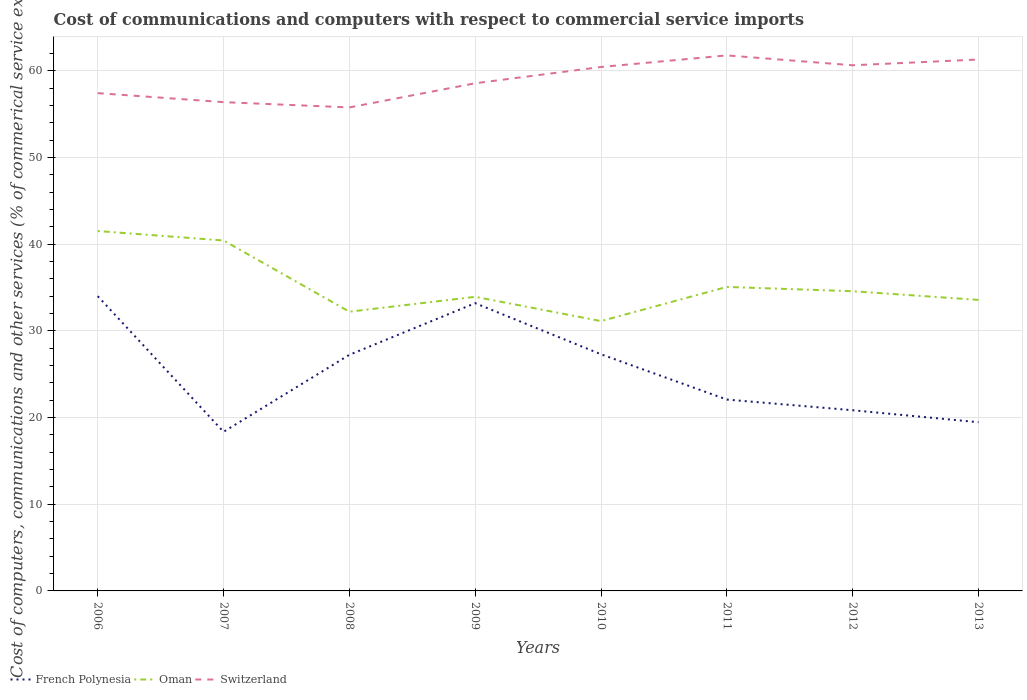Across all years, what is the maximum cost of communications and computers in French Polynesia?
Your answer should be very brief. 18.36. What is the total cost of communications and computers in French Polynesia in the graph?
Your answer should be very brief. 13.16. What is the difference between the highest and the second highest cost of communications and computers in Switzerland?
Provide a short and direct response. 6. Is the cost of communications and computers in French Polynesia strictly greater than the cost of communications and computers in Oman over the years?
Give a very brief answer. Yes. How many lines are there?
Offer a very short reply. 3. Does the graph contain any zero values?
Keep it short and to the point. No. Does the graph contain grids?
Ensure brevity in your answer.  Yes. Where does the legend appear in the graph?
Give a very brief answer. Bottom left. How are the legend labels stacked?
Your answer should be very brief. Horizontal. What is the title of the graph?
Your response must be concise. Cost of communications and computers with respect to commercial service imports. Does "Germany" appear as one of the legend labels in the graph?
Make the answer very short. No. What is the label or title of the X-axis?
Give a very brief answer. Years. What is the label or title of the Y-axis?
Your answer should be very brief. Cost of computers, communications and other services (% of commerical service exports). What is the Cost of computers, communications and other services (% of commerical service exports) in French Polynesia in 2006?
Provide a short and direct response. 34. What is the Cost of computers, communications and other services (% of commerical service exports) of Oman in 2006?
Offer a terse response. 41.52. What is the Cost of computers, communications and other services (% of commerical service exports) in Switzerland in 2006?
Provide a succinct answer. 57.43. What is the Cost of computers, communications and other services (% of commerical service exports) in French Polynesia in 2007?
Provide a short and direct response. 18.36. What is the Cost of computers, communications and other services (% of commerical service exports) in Oman in 2007?
Offer a terse response. 40.43. What is the Cost of computers, communications and other services (% of commerical service exports) in Switzerland in 2007?
Offer a very short reply. 56.39. What is the Cost of computers, communications and other services (% of commerical service exports) in French Polynesia in 2008?
Provide a succinct answer. 27.24. What is the Cost of computers, communications and other services (% of commerical service exports) of Oman in 2008?
Keep it short and to the point. 32.21. What is the Cost of computers, communications and other services (% of commerical service exports) of Switzerland in 2008?
Offer a terse response. 55.78. What is the Cost of computers, communications and other services (% of commerical service exports) in French Polynesia in 2009?
Your answer should be very brief. 33.2. What is the Cost of computers, communications and other services (% of commerical service exports) in Oman in 2009?
Ensure brevity in your answer.  33.93. What is the Cost of computers, communications and other services (% of commerical service exports) of Switzerland in 2009?
Keep it short and to the point. 58.57. What is the Cost of computers, communications and other services (% of commerical service exports) in French Polynesia in 2010?
Ensure brevity in your answer.  27.3. What is the Cost of computers, communications and other services (% of commerical service exports) in Oman in 2010?
Keep it short and to the point. 31.13. What is the Cost of computers, communications and other services (% of commerical service exports) of Switzerland in 2010?
Provide a short and direct response. 60.44. What is the Cost of computers, communications and other services (% of commerical service exports) of French Polynesia in 2011?
Your answer should be compact. 22.08. What is the Cost of computers, communications and other services (% of commerical service exports) of Oman in 2011?
Ensure brevity in your answer.  35.07. What is the Cost of computers, communications and other services (% of commerical service exports) in Switzerland in 2011?
Provide a succinct answer. 61.78. What is the Cost of computers, communications and other services (% of commerical service exports) of French Polynesia in 2012?
Provide a short and direct response. 20.84. What is the Cost of computers, communications and other services (% of commerical service exports) of Oman in 2012?
Your response must be concise. 34.57. What is the Cost of computers, communications and other services (% of commerical service exports) of Switzerland in 2012?
Your answer should be compact. 60.64. What is the Cost of computers, communications and other services (% of commerical service exports) of French Polynesia in 2013?
Your answer should be compact. 19.46. What is the Cost of computers, communications and other services (% of commerical service exports) in Oman in 2013?
Your answer should be compact. 33.58. What is the Cost of computers, communications and other services (% of commerical service exports) in Switzerland in 2013?
Offer a very short reply. 61.31. Across all years, what is the maximum Cost of computers, communications and other services (% of commerical service exports) of French Polynesia?
Keep it short and to the point. 34. Across all years, what is the maximum Cost of computers, communications and other services (% of commerical service exports) of Oman?
Ensure brevity in your answer.  41.52. Across all years, what is the maximum Cost of computers, communications and other services (% of commerical service exports) of Switzerland?
Your answer should be very brief. 61.78. Across all years, what is the minimum Cost of computers, communications and other services (% of commerical service exports) in French Polynesia?
Give a very brief answer. 18.36. Across all years, what is the minimum Cost of computers, communications and other services (% of commerical service exports) of Oman?
Give a very brief answer. 31.13. Across all years, what is the minimum Cost of computers, communications and other services (% of commerical service exports) in Switzerland?
Offer a very short reply. 55.78. What is the total Cost of computers, communications and other services (% of commerical service exports) of French Polynesia in the graph?
Offer a very short reply. 202.48. What is the total Cost of computers, communications and other services (% of commerical service exports) in Oman in the graph?
Ensure brevity in your answer.  282.44. What is the total Cost of computers, communications and other services (% of commerical service exports) of Switzerland in the graph?
Offer a very short reply. 472.34. What is the difference between the Cost of computers, communications and other services (% of commerical service exports) in French Polynesia in 2006 and that in 2007?
Your answer should be very brief. 15.65. What is the difference between the Cost of computers, communications and other services (% of commerical service exports) of Oman in 2006 and that in 2007?
Your answer should be compact. 1.09. What is the difference between the Cost of computers, communications and other services (% of commerical service exports) of Switzerland in 2006 and that in 2007?
Provide a short and direct response. 1.04. What is the difference between the Cost of computers, communications and other services (% of commerical service exports) of French Polynesia in 2006 and that in 2008?
Offer a terse response. 6.76. What is the difference between the Cost of computers, communications and other services (% of commerical service exports) of Oman in 2006 and that in 2008?
Your answer should be very brief. 9.31. What is the difference between the Cost of computers, communications and other services (% of commerical service exports) in Switzerland in 2006 and that in 2008?
Offer a very short reply. 1.65. What is the difference between the Cost of computers, communications and other services (% of commerical service exports) of French Polynesia in 2006 and that in 2009?
Make the answer very short. 0.81. What is the difference between the Cost of computers, communications and other services (% of commerical service exports) of Oman in 2006 and that in 2009?
Give a very brief answer. 7.59. What is the difference between the Cost of computers, communications and other services (% of commerical service exports) of Switzerland in 2006 and that in 2009?
Keep it short and to the point. -1.14. What is the difference between the Cost of computers, communications and other services (% of commerical service exports) of French Polynesia in 2006 and that in 2010?
Give a very brief answer. 6.7. What is the difference between the Cost of computers, communications and other services (% of commerical service exports) of Oman in 2006 and that in 2010?
Provide a succinct answer. 10.39. What is the difference between the Cost of computers, communications and other services (% of commerical service exports) of Switzerland in 2006 and that in 2010?
Keep it short and to the point. -3.02. What is the difference between the Cost of computers, communications and other services (% of commerical service exports) of French Polynesia in 2006 and that in 2011?
Provide a short and direct response. 11.93. What is the difference between the Cost of computers, communications and other services (% of commerical service exports) in Oman in 2006 and that in 2011?
Offer a terse response. 6.45. What is the difference between the Cost of computers, communications and other services (% of commerical service exports) of Switzerland in 2006 and that in 2011?
Your response must be concise. -4.35. What is the difference between the Cost of computers, communications and other services (% of commerical service exports) in French Polynesia in 2006 and that in 2012?
Offer a very short reply. 13.16. What is the difference between the Cost of computers, communications and other services (% of commerical service exports) of Oman in 2006 and that in 2012?
Provide a succinct answer. 6.94. What is the difference between the Cost of computers, communications and other services (% of commerical service exports) of Switzerland in 2006 and that in 2012?
Offer a terse response. -3.21. What is the difference between the Cost of computers, communications and other services (% of commerical service exports) in French Polynesia in 2006 and that in 2013?
Keep it short and to the point. 14.54. What is the difference between the Cost of computers, communications and other services (% of commerical service exports) of Oman in 2006 and that in 2013?
Your response must be concise. 7.94. What is the difference between the Cost of computers, communications and other services (% of commerical service exports) of Switzerland in 2006 and that in 2013?
Keep it short and to the point. -3.88. What is the difference between the Cost of computers, communications and other services (% of commerical service exports) in French Polynesia in 2007 and that in 2008?
Your answer should be compact. -8.88. What is the difference between the Cost of computers, communications and other services (% of commerical service exports) of Oman in 2007 and that in 2008?
Make the answer very short. 8.22. What is the difference between the Cost of computers, communications and other services (% of commerical service exports) of Switzerland in 2007 and that in 2008?
Your response must be concise. 0.61. What is the difference between the Cost of computers, communications and other services (% of commerical service exports) of French Polynesia in 2007 and that in 2009?
Provide a short and direct response. -14.84. What is the difference between the Cost of computers, communications and other services (% of commerical service exports) of Oman in 2007 and that in 2009?
Offer a terse response. 6.5. What is the difference between the Cost of computers, communications and other services (% of commerical service exports) of Switzerland in 2007 and that in 2009?
Provide a short and direct response. -2.18. What is the difference between the Cost of computers, communications and other services (% of commerical service exports) of French Polynesia in 2007 and that in 2010?
Make the answer very short. -8.95. What is the difference between the Cost of computers, communications and other services (% of commerical service exports) in Oman in 2007 and that in 2010?
Make the answer very short. 9.3. What is the difference between the Cost of computers, communications and other services (% of commerical service exports) in Switzerland in 2007 and that in 2010?
Keep it short and to the point. -4.06. What is the difference between the Cost of computers, communications and other services (% of commerical service exports) in French Polynesia in 2007 and that in 2011?
Offer a very short reply. -3.72. What is the difference between the Cost of computers, communications and other services (% of commerical service exports) in Oman in 2007 and that in 2011?
Your response must be concise. 5.36. What is the difference between the Cost of computers, communications and other services (% of commerical service exports) in Switzerland in 2007 and that in 2011?
Ensure brevity in your answer.  -5.39. What is the difference between the Cost of computers, communications and other services (% of commerical service exports) in French Polynesia in 2007 and that in 2012?
Provide a succinct answer. -2.49. What is the difference between the Cost of computers, communications and other services (% of commerical service exports) in Oman in 2007 and that in 2012?
Provide a succinct answer. 5.85. What is the difference between the Cost of computers, communications and other services (% of commerical service exports) in Switzerland in 2007 and that in 2012?
Make the answer very short. -4.25. What is the difference between the Cost of computers, communications and other services (% of commerical service exports) in French Polynesia in 2007 and that in 2013?
Offer a terse response. -1.11. What is the difference between the Cost of computers, communications and other services (% of commerical service exports) of Oman in 2007 and that in 2013?
Ensure brevity in your answer.  6.85. What is the difference between the Cost of computers, communications and other services (% of commerical service exports) in Switzerland in 2007 and that in 2013?
Keep it short and to the point. -4.92. What is the difference between the Cost of computers, communications and other services (% of commerical service exports) of French Polynesia in 2008 and that in 2009?
Provide a short and direct response. -5.96. What is the difference between the Cost of computers, communications and other services (% of commerical service exports) of Oman in 2008 and that in 2009?
Give a very brief answer. -1.72. What is the difference between the Cost of computers, communications and other services (% of commerical service exports) in Switzerland in 2008 and that in 2009?
Your answer should be compact. -2.79. What is the difference between the Cost of computers, communications and other services (% of commerical service exports) of French Polynesia in 2008 and that in 2010?
Offer a very short reply. -0.06. What is the difference between the Cost of computers, communications and other services (% of commerical service exports) in Switzerland in 2008 and that in 2010?
Offer a terse response. -4.67. What is the difference between the Cost of computers, communications and other services (% of commerical service exports) of French Polynesia in 2008 and that in 2011?
Provide a short and direct response. 5.16. What is the difference between the Cost of computers, communications and other services (% of commerical service exports) of Oman in 2008 and that in 2011?
Your response must be concise. -2.86. What is the difference between the Cost of computers, communications and other services (% of commerical service exports) of Switzerland in 2008 and that in 2011?
Give a very brief answer. -6. What is the difference between the Cost of computers, communications and other services (% of commerical service exports) of French Polynesia in 2008 and that in 2012?
Make the answer very short. 6.39. What is the difference between the Cost of computers, communications and other services (% of commerical service exports) in Oman in 2008 and that in 2012?
Your response must be concise. -2.36. What is the difference between the Cost of computers, communications and other services (% of commerical service exports) of Switzerland in 2008 and that in 2012?
Your response must be concise. -4.86. What is the difference between the Cost of computers, communications and other services (% of commerical service exports) in French Polynesia in 2008 and that in 2013?
Provide a succinct answer. 7.78. What is the difference between the Cost of computers, communications and other services (% of commerical service exports) of Oman in 2008 and that in 2013?
Make the answer very short. -1.36. What is the difference between the Cost of computers, communications and other services (% of commerical service exports) in Switzerland in 2008 and that in 2013?
Provide a short and direct response. -5.53. What is the difference between the Cost of computers, communications and other services (% of commerical service exports) of French Polynesia in 2009 and that in 2010?
Provide a short and direct response. 5.9. What is the difference between the Cost of computers, communications and other services (% of commerical service exports) in Oman in 2009 and that in 2010?
Provide a short and direct response. 2.8. What is the difference between the Cost of computers, communications and other services (% of commerical service exports) of Switzerland in 2009 and that in 2010?
Ensure brevity in your answer.  -1.88. What is the difference between the Cost of computers, communications and other services (% of commerical service exports) in French Polynesia in 2009 and that in 2011?
Give a very brief answer. 11.12. What is the difference between the Cost of computers, communications and other services (% of commerical service exports) in Oman in 2009 and that in 2011?
Keep it short and to the point. -1.14. What is the difference between the Cost of computers, communications and other services (% of commerical service exports) in Switzerland in 2009 and that in 2011?
Give a very brief answer. -3.21. What is the difference between the Cost of computers, communications and other services (% of commerical service exports) in French Polynesia in 2009 and that in 2012?
Offer a very short reply. 12.35. What is the difference between the Cost of computers, communications and other services (% of commerical service exports) in Oman in 2009 and that in 2012?
Make the answer very short. -0.64. What is the difference between the Cost of computers, communications and other services (% of commerical service exports) of Switzerland in 2009 and that in 2012?
Keep it short and to the point. -2.07. What is the difference between the Cost of computers, communications and other services (% of commerical service exports) of French Polynesia in 2009 and that in 2013?
Your answer should be compact. 13.73. What is the difference between the Cost of computers, communications and other services (% of commerical service exports) of Oman in 2009 and that in 2013?
Keep it short and to the point. 0.36. What is the difference between the Cost of computers, communications and other services (% of commerical service exports) of Switzerland in 2009 and that in 2013?
Ensure brevity in your answer.  -2.74. What is the difference between the Cost of computers, communications and other services (% of commerical service exports) in French Polynesia in 2010 and that in 2011?
Your answer should be very brief. 5.22. What is the difference between the Cost of computers, communications and other services (% of commerical service exports) of Oman in 2010 and that in 2011?
Offer a very short reply. -3.94. What is the difference between the Cost of computers, communications and other services (% of commerical service exports) of Switzerland in 2010 and that in 2011?
Your answer should be compact. -1.34. What is the difference between the Cost of computers, communications and other services (% of commerical service exports) in French Polynesia in 2010 and that in 2012?
Make the answer very short. 6.46. What is the difference between the Cost of computers, communications and other services (% of commerical service exports) in Oman in 2010 and that in 2012?
Ensure brevity in your answer.  -3.45. What is the difference between the Cost of computers, communications and other services (% of commerical service exports) of Switzerland in 2010 and that in 2012?
Offer a terse response. -0.2. What is the difference between the Cost of computers, communications and other services (% of commerical service exports) of French Polynesia in 2010 and that in 2013?
Offer a terse response. 7.84. What is the difference between the Cost of computers, communications and other services (% of commerical service exports) of Oman in 2010 and that in 2013?
Offer a very short reply. -2.45. What is the difference between the Cost of computers, communications and other services (% of commerical service exports) of Switzerland in 2010 and that in 2013?
Provide a succinct answer. -0.86. What is the difference between the Cost of computers, communications and other services (% of commerical service exports) of French Polynesia in 2011 and that in 2012?
Provide a succinct answer. 1.23. What is the difference between the Cost of computers, communications and other services (% of commerical service exports) in Oman in 2011 and that in 2012?
Ensure brevity in your answer.  0.5. What is the difference between the Cost of computers, communications and other services (% of commerical service exports) of Switzerland in 2011 and that in 2012?
Your answer should be very brief. 1.14. What is the difference between the Cost of computers, communications and other services (% of commerical service exports) in French Polynesia in 2011 and that in 2013?
Offer a terse response. 2.61. What is the difference between the Cost of computers, communications and other services (% of commerical service exports) in Oman in 2011 and that in 2013?
Provide a short and direct response. 1.49. What is the difference between the Cost of computers, communications and other services (% of commerical service exports) in Switzerland in 2011 and that in 2013?
Offer a terse response. 0.47. What is the difference between the Cost of computers, communications and other services (% of commerical service exports) in French Polynesia in 2012 and that in 2013?
Make the answer very short. 1.38. What is the difference between the Cost of computers, communications and other services (% of commerical service exports) of Switzerland in 2012 and that in 2013?
Make the answer very short. -0.67. What is the difference between the Cost of computers, communications and other services (% of commerical service exports) of French Polynesia in 2006 and the Cost of computers, communications and other services (% of commerical service exports) of Oman in 2007?
Ensure brevity in your answer.  -6.42. What is the difference between the Cost of computers, communications and other services (% of commerical service exports) of French Polynesia in 2006 and the Cost of computers, communications and other services (% of commerical service exports) of Switzerland in 2007?
Your answer should be very brief. -22.39. What is the difference between the Cost of computers, communications and other services (% of commerical service exports) of Oman in 2006 and the Cost of computers, communications and other services (% of commerical service exports) of Switzerland in 2007?
Provide a succinct answer. -14.87. What is the difference between the Cost of computers, communications and other services (% of commerical service exports) of French Polynesia in 2006 and the Cost of computers, communications and other services (% of commerical service exports) of Oman in 2008?
Your answer should be compact. 1.79. What is the difference between the Cost of computers, communications and other services (% of commerical service exports) in French Polynesia in 2006 and the Cost of computers, communications and other services (% of commerical service exports) in Switzerland in 2008?
Provide a succinct answer. -21.77. What is the difference between the Cost of computers, communications and other services (% of commerical service exports) of Oman in 2006 and the Cost of computers, communications and other services (% of commerical service exports) of Switzerland in 2008?
Give a very brief answer. -14.26. What is the difference between the Cost of computers, communications and other services (% of commerical service exports) of French Polynesia in 2006 and the Cost of computers, communications and other services (% of commerical service exports) of Oman in 2009?
Make the answer very short. 0.07. What is the difference between the Cost of computers, communications and other services (% of commerical service exports) in French Polynesia in 2006 and the Cost of computers, communications and other services (% of commerical service exports) in Switzerland in 2009?
Your answer should be compact. -24.56. What is the difference between the Cost of computers, communications and other services (% of commerical service exports) of Oman in 2006 and the Cost of computers, communications and other services (% of commerical service exports) of Switzerland in 2009?
Offer a terse response. -17.05. What is the difference between the Cost of computers, communications and other services (% of commerical service exports) in French Polynesia in 2006 and the Cost of computers, communications and other services (% of commerical service exports) in Oman in 2010?
Give a very brief answer. 2.87. What is the difference between the Cost of computers, communications and other services (% of commerical service exports) of French Polynesia in 2006 and the Cost of computers, communications and other services (% of commerical service exports) of Switzerland in 2010?
Offer a terse response. -26.44. What is the difference between the Cost of computers, communications and other services (% of commerical service exports) in Oman in 2006 and the Cost of computers, communications and other services (% of commerical service exports) in Switzerland in 2010?
Keep it short and to the point. -18.93. What is the difference between the Cost of computers, communications and other services (% of commerical service exports) in French Polynesia in 2006 and the Cost of computers, communications and other services (% of commerical service exports) in Oman in 2011?
Offer a terse response. -1.07. What is the difference between the Cost of computers, communications and other services (% of commerical service exports) in French Polynesia in 2006 and the Cost of computers, communications and other services (% of commerical service exports) in Switzerland in 2011?
Provide a succinct answer. -27.78. What is the difference between the Cost of computers, communications and other services (% of commerical service exports) of Oman in 2006 and the Cost of computers, communications and other services (% of commerical service exports) of Switzerland in 2011?
Your answer should be very brief. -20.26. What is the difference between the Cost of computers, communications and other services (% of commerical service exports) in French Polynesia in 2006 and the Cost of computers, communications and other services (% of commerical service exports) in Oman in 2012?
Offer a terse response. -0.57. What is the difference between the Cost of computers, communications and other services (% of commerical service exports) in French Polynesia in 2006 and the Cost of computers, communications and other services (% of commerical service exports) in Switzerland in 2012?
Keep it short and to the point. -26.64. What is the difference between the Cost of computers, communications and other services (% of commerical service exports) in Oman in 2006 and the Cost of computers, communications and other services (% of commerical service exports) in Switzerland in 2012?
Ensure brevity in your answer.  -19.12. What is the difference between the Cost of computers, communications and other services (% of commerical service exports) in French Polynesia in 2006 and the Cost of computers, communications and other services (% of commerical service exports) in Oman in 2013?
Offer a terse response. 0.43. What is the difference between the Cost of computers, communications and other services (% of commerical service exports) of French Polynesia in 2006 and the Cost of computers, communications and other services (% of commerical service exports) of Switzerland in 2013?
Keep it short and to the point. -27.3. What is the difference between the Cost of computers, communications and other services (% of commerical service exports) of Oman in 2006 and the Cost of computers, communications and other services (% of commerical service exports) of Switzerland in 2013?
Ensure brevity in your answer.  -19.79. What is the difference between the Cost of computers, communications and other services (% of commerical service exports) of French Polynesia in 2007 and the Cost of computers, communications and other services (% of commerical service exports) of Oman in 2008?
Your answer should be very brief. -13.86. What is the difference between the Cost of computers, communications and other services (% of commerical service exports) of French Polynesia in 2007 and the Cost of computers, communications and other services (% of commerical service exports) of Switzerland in 2008?
Provide a short and direct response. -37.42. What is the difference between the Cost of computers, communications and other services (% of commerical service exports) of Oman in 2007 and the Cost of computers, communications and other services (% of commerical service exports) of Switzerland in 2008?
Make the answer very short. -15.35. What is the difference between the Cost of computers, communications and other services (% of commerical service exports) in French Polynesia in 2007 and the Cost of computers, communications and other services (% of commerical service exports) in Oman in 2009?
Your answer should be compact. -15.58. What is the difference between the Cost of computers, communications and other services (% of commerical service exports) of French Polynesia in 2007 and the Cost of computers, communications and other services (% of commerical service exports) of Switzerland in 2009?
Your answer should be very brief. -40.21. What is the difference between the Cost of computers, communications and other services (% of commerical service exports) in Oman in 2007 and the Cost of computers, communications and other services (% of commerical service exports) in Switzerland in 2009?
Your response must be concise. -18.14. What is the difference between the Cost of computers, communications and other services (% of commerical service exports) of French Polynesia in 2007 and the Cost of computers, communications and other services (% of commerical service exports) of Oman in 2010?
Offer a very short reply. -12.77. What is the difference between the Cost of computers, communications and other services (% of commerical service exports) of French Polynesia in 2007 and the Cost of computers, communications and other services (% of commerical service exports) of Switzerland in 2010?
Offer a terse response. -42.09. What is the difference between the Cost of computers, communications and other services (% of commerical service exports) in Oman in 2007 and the Cost of computers, communications and other services (% of commerical service exports) in Switzerland in 2010?
Keep it short and to the point. -20.02. What is the difference between the Cost of computers, communications and other services (% of commerical service exports) of French Polynesia in 2007 and the Cost of computers, communications and other services (% of commerical service exports) of Oman in 2011?
Give a very brief answer. -16.72. What is the difference between the Cost of computers, communications and other services (% of commerical service exports) of French Polynesia in 2007 and the Cost of computers, communications and other services (% of commerical service exports) of Switzerland in 2011?
Give a very brief answer. -43.43. What is the difference between the Cost of computers, communications and other services (% of commerical service exports) in Oman in 2007 and the Cost of computers, communications and other services (% of commerical service exports) in Switzerland in 2011?
Your answer should be compact. -21.35. What is the difference between the Cost of computers, communications and other services (% of commerical service exports) in French Polynesia in 2007 and the Cost of computers, communications and other services (% of commerical service exports) in Oman in 2012?
Offer a very short reply. -16.22. What is the difference between the Cost of computers, communications and other services (% of commerical service exports) in French Polynesia in 2007 and the Cost of computers, communications and other services (% of commerical service exports) in Switzerland in 2012?
Offer a terse response. -42.29. What is the difference between the Cost of computers, communications and other services (% of commerical service exports) in Oman in 2007 and the Cost of computers, communications and other services (% of commerical service exports) in Switzerland in 2012?
Ensure brevity in your answer.  -20.21. What is the difference between the Cost of computers, communications and other services (% of commerical service exports) of French Polynesia in 2007 and the Cost of computers, communications and other services (% of commerical service exports) of Oman in 2013?
Ensure brevity in your answer.  -15.22. What is the difference between the Cost of computers, communications and other services (% of commerical service exports) in French Polynesia in 2007 and the Cost of computers, communications and other services (% of commerical service exports) in Switzerland in 2013?
Offer a terse response. -42.95. What is the difference between the Cost of computers, communications and other services (% of commerical service exports) in Oman in 2007 and the Cost of computers, communications and other services (% of commerical service exports) in Switzerland in 2013?
Your answer should be very brief. -20.88. What is the difference between the Cost of computers, communications and other services (% of commerical service exports) of French Polynesia in 2008 and the Cost of computers, communications and other services (% of commerical service exports) of Oman in 2009?
Ensure brevity in your answer.  -6.69. What is the difference between the Cost of computers, communications and other services (% of commerical service exports) of French Polynesia in 2008 and the Cost of computers, communications and other services (% of commerical service exports) of Switzerland in 2009?
Your answer should be very brief. -31.33. What is the difference between the Cost of computers, communications and other services (% of commerical service exports) of Oman in 2008 and the Cost of computers, communications and other services (% of commerical service exports) of Switzerland in 2009?
Offer a very short reply. -26.35. What is the difference between the Cost of computers, communications and other services (% of commerical service exports) of French Polynesia in 2008 and the Cost of computers, communications and other services (% of commerical service exports) of Oman in 2010?
Provide a succinct answer. -3.89. What is the difference between the Cost of computers, communications and other services (% of commerical service exports) of French Polynesia in 2008 and the Cost of computers, communications and other services (% of commerical service exports) of Switzerland in 2010?
Your response must be concise. -33.2. What is the difference between the Cost of computers, communications and other services (% of commerical service exports) of Oman in 2008 and the Cost of computers, communications and other services (% of commerical service exports) of Switzerland in 2010?
Your response must be concise. -28.23. What is the difference between the Cost of computers, communications and other services (% of commerical service exports) of French Polynesia in 2008 and the Cost of computers, communications and other services (% of commerical service exports) of Oman in 2011?
Make the answer very short. -7.83. What is the difference between the Cost of computers, communications and other services (% of commerical service exports) in French Polynesia in 2008 and the Cost of computers, communications and other services (% of commerical service exports) in Switzerland in 2011?
Offer a terse response. -34.54. What is the difference between the Cost of computers, communications and other services (% of commerical service exports) in Oman in 2008 and the Cost of computers, communications and other services (% of commerical service exports) in Switzerland in 2011?
Offer a very short reply. -29.57. What is the difference between the Cost of computers, communications and other services (% of commerical service exports) in French Polynesia in 2008 and the Cost of computers, communications and other services (% of commerical service exports) in Oman in 2012?
Your response must be concise. -7.34. What is the difference between the Cost of computers, communications and other services (% of commerical service exports) of French Polynesia in 2008 and the Cost of computers, communications and other services (% of commerical service exports) of Switzerland in 2012?
Your answer should be very brief. -33.4. What is the difference between the Cost of computers, communications and other services (% of commerical service exports) in Oman in 2008 and the Cost of computers, communications and other services (% of commerical service exports) in Switzerland in 2012?
Offer a very short reply. -28.43. What is the difference between the Cost of computers, communications and other services (% of commerical service exports) in French Polynesia in 2008 and the Cost of computers, communications and other services (% of commerical service exports) in Oman in 2013?
Keep it short and to the point. -6.34. What is the difference between the Cost of computers, communications and other services (% of commerical service exports) in French Polynesia in 2008 and the Cost of computers, communications and other services (% of commerical service exports) in Switzerland in 2013?
Provide a short and direct response. -34.07. What is the difference between the Cost of computers, communications and other services (% of commerical service exports) in Oman in 2008 and the Cost of computers, communications and other services (% of commerical service exports) in Switzerland in 2013?
Offer a terse response. -29.09. What is the difference between the Cost of computers, communications and other services (% of commerical service exports) of French Polynesia in 2009 and the Cost of computers, communications and other services (% of commerical service exports) of Oman in 2010?
Keep it short and to the point. 2.07. What is the difference between the Cost of computers, communications and other services (% of commerical service exports) of French Polynesia in 2009 and the Cost of computers, communications and other services (% of commerical service exports) of Switzerland in 2010?
Give a very brief answer. -27.25. What is the difference between the Cost of computers, communications and other services (% of commerical service exports) of Oman in 2009 and the Cost of computers, communications and other services (% of commerical service exports) of Switzerland in 2010?
Keep it short and to the point. -26.51. What is the difference between the Cost of computers, communications and other services (% of commerical service exports) of French Polynesia in 2009 and the Cost of computers, communications and other services (% of commerical service exports) of Oman in 2011?
Make the answer very short. -1.87. What is the difference between the Cost of computers, communications and other services (% of commerical service exports) of French Polynesia in 2009 and the Cost of computers, communications and other services (% of commerical service exports) of Switzerland in 2011?
Give a very brief answer. -28.58. What is the difference between the Cost of computers, communications and other services (% of commerical service exports) of Oman in 2009 and the Cost of computers, communications and other services (% of commerical service exports) of Switzerland in 2011?
Offer a very short reply. -27.85. What is the difference between the Cost of computers, communications and other services (% of commerical service exports) of French Polynesia in 2009 and the Cost of computers, communications and other services (% of commerical service exports) of Oman in 2012?
Your answer should be very brief. -1.38. What is the difference between the Cost of computers, communications and other services (% of commerical service exports) of French Polynesia in 2009 and the Cost of computers, communications and other services (% of commerical service exports) of Switzerland in 2012?
Your answer should be compact. -27.44. What is the difference between the Cost of computers, communications and other services (% of commerical service exports) of Oman in 2009 and the Cost of computers, communications and other services (% of commerical service exports) of Switzerland in 2012?
Your answer should be very brief. -26.71. What is the difference between the Cost of computers, communications and other services (% of commerical service exports) of French Polynesia in 2009 and the Cost of computers, communications and other services (% of commerical service exports) of Oman in 2013?
Your response must be concise. -0.38. What is the difference between the Cost of computers, communications and other services (% of commerical service exports) in French Polynesia in 2009 and the Cost of computers, communications and other services (% of commerical service exports) in Switzerland in 2013?
Your response must be concise. -28.11. What is the difference between the Cost of computers, communications and other services (% of commerical service exports) of Oman in 2009 and the Cost of computers, communications and other services (% of commerical service exports) of Switzerland in 2013?
Your answer should be very brief. -27.38. What is the difference between the Cost of computers, communications and other services (% of commerical service exports) of French Polynesia in 2010 and the Cost of computers, communications and other services (% of commerical service exports) of Oman in 2011?
Your response must be concise. -7.77. What is the difference between the Cost of computers, communications and other services (% of commerical service exports) of French Polynesia in 2010 and the Cost of computers, communications and other services (% of commerical service exports) of Switzerland in 2011?
Give a very brief answer. -34.48. What is the difference between the Cost of computers, communications and other services (% of commerical service exports) of Oman in 2010 and the Cost of computers, communications and other services (% of commerical service exports) of Switzerland in 2011?
Ensure brevity in your answer.  -30.65. What is the difference between the Cost of computers, communications and other services (% of commerical service exports) in French Polynesia in 2010 and the Cost of computers, communications and other services (% of commerical service exports) in Oman in 2012?
Keep it short and to the point. -7.27. What is the difference between the Cost of computers, communications and other services (% of commerical service exports) in French Polynesia in 2010 and the Cost of computers, communications and other services (% of commerical service exports) in Switzerland in 2012?
Keep it short and to the point. -33.34. What is the difference between the Cost of computers, communications and other services (% of commerical service exports) of Oman in 2010 and the Cost of computers, communications and other services (% of commerical service exports) of Switzerland in 2012?
Offer a terse response. -29.51. What is the difference between the Cost of computers, communications and other services (% of commerical service exports) of French Polynesia in 2010 and the Cost of computers, communications and other services (% of commerical service exports) of Oman in 2013?
Offer a very short reply. -6.28. What is the difference between the Cost of computers, communications and other services (% of commerical service exports) of French Polynesia in 2010 and the Cost of computers, communications and other services (% of commerical service exports) of Switzerland in 2013?
Offer a very short reply. -34.01. What is the difference between the Cost of computers, communications and other services (% of commerical service exports) of Oman in 2010 and the Cost of computers, communications and other services (% of commerical service exports) of Switzerland in 2013?
Your response must be concise. -30.18. What is the difference between the Cost of computers, communications and other services (% of commerical service exports) in French Polynesia in 2011 and the Cost of computers, communications and other services (% of commerical service exports) in Oman in 2012?
Give a very brief answer. -12.5. What is the difference between the Cost of computers, communications and other services (% of commerical service exports) in French Polynesia in 2011 and the Cost of computers, communications and other services (% of commerical service exports) in Switzerland in 2012?
Provide a short and direct response. -38.56. What is the difference between the Cost of computers, communications and other services (% of commerical service exports) of Oman in 2011 and the Cost of computers, communications and other services (% of commerical service exports) of Switzerland in 2012?
Your answer should be very brief. -25.57. What is the difference between the Cost of computers, communications and other services (% of commerical service exports) in French Polynesia in 2011 and the Cost of computers, communications and other services (% of commerical service exports) in Oman in 2013?
Provide a succinct answer. -11.5. What is the difference between the Cost of computers, communications and other services (% of commerical service exports) of French Polynesia in 2011 and the Cost of computers, communications and other services (% of commerical service exports) of Switzerland in 2013?
Your answer should be compact. -39.23. What is the difference between the Cost of computers, communications and other services (% of commerical service exports) in Oman in 2011 and the Cost of computers, communications and other services (% of commerical service exports) in Switzerland in 2013?
Your response must be concise. -26.24. What is the difference between the Cost of computers, communications and other services (% of commerical service exports) of French Polynesia in 2012 and the Cost of computers, communications and other services (% of commerical service exports) of Oman in 2013?
Your response must be concise. -12.73. What is the difference between the Cost of computers, communications and other services (% of commerical service exports) in French Polynesia in 2012 and the Cost of computers, communications and other services (% of commerical service exports) in Switzerland in 2013?
Offer a terse response. -40.46. What is the difference between the Cost of computers, communications and other services (% of commerical service exports) of Oman in 2012 and the Cost of computers, communications and other services (% of commerical service exports) of Switzerland in 2013?
Your response must be concise. -26.73. What is the average Cost of computers, communications and other services (% of commerical service exports) of French Polynesia per year?
Your answer should be very brief. 25.31. What is the average Cost of computers, communications and other services (% of commerical service exports) in Oman per year?
Make the answer very short. 35.3. What is the average Cost of computers, communications and other services (% of commerical service exports) in Switzerland per year?
Offer a terse response. 59.04. In the year 2006, what is the difference between the Cost of computers, communications and other services (% of commerical service exports) of French Polynesia and Cost of computers, communications and other services (% of commerical service exports) of Oman?
Provide a short and direct response. -7.51. In the year 2006, what is the difference between the Cost of computers, communications and other services (% of commerical service exports) in French Polynesia and Cost of computers, communications and other services (% of commerical service exports) in Switzerland?
Offer a very short reply. -23.43. In the year 2006, what is the difference between the Cost of computers, communications and other services (% of commerical service exports) in Oman and Cost of computers, communications and other services (% of commerical service exports) in Switzerland?
Provide a short and direct response. -15.91. In the year 2007, what is the difference between the Cost of computers, communications and other services (% of commerical service exports) of French Polynesia and Cost of computers, communications and other services (% of commerical service exports) of Oman?
Provide a succinct answer. -22.07. In the year 2007, what is the difference between the Cost of computers, communications and other services (% of commerical service exports) of French Polynesia and Cost of computers, communications and other services (% of commerical service exports) of Switzerland?
Offer a terse response. -38.03. In the year 2007, what is the difference between the Cost of computers, communications and other services (% of commerical service exports) in Oman and Cost of computers, communications and other services (% of commerical service exports) in Switzerland?
Provide a succinct answer. -15.96. In the year 2008, what is the difference between the Cost of computers, communications and other services (% of commerical service exports) in French Polynesia and Cost of computers, communications and other services (% of commerical service exports) in Oman?
Offer a terse response. -4.97. In the year 2008, what is the difference between the Cost of computers, communications and other services (% of commerical service exports) of French Polynesia and Cost of computers, communications and other services (% of commerical service exports) of Switzerland?
Offer a very short reply. -28.54. In the year 2008, what is the difference between the Cost of computers, communications and other services (% of commerical service exports) in Oman and Cost of computers, communications and other services (% of commerical service exports) in Switzerland?
Offer a very short reply. -23.57. In the year 2009, what is the difference between the Cost of computers, communications and other services (% of commerical service exports) of French Polynesia and Cost of computers, communications and other services (% of commerical service exports) of Oman?
Make the answer very short. -0.74. In the year 2009, what is the difference between the Cost of computers, communications and other services (% of commerical service exports) in French Polynesia and Cost of computers, communications and other services (% of commerical service exports) in Switzerland?
Provide a succinct answer. -25.37. In the year 2009, what is the difference between the Cost of computers, communications and other services (% of commerical service exports) of Oman and Cost of computers, communications and other services (% of commerical service exports) of Switzerland?
Your response must be concise. -24.64. In the year 2010, what is the difference between the Cost of computers, communications and other services (% of commerical service exports) of French Polynesia and Cost of computers, communications and other services (% of commerical service exports) of Oman?
Your response must be concise. -3.83. In the year 2010, what is the difference between the Cost of computers, communications and other services (% of commerical service exports) in French Polynesia and Cost of computers, communications and other services (% of commerical service exports) in Switzerland?
Your answer should be very brief. -33.14. In the year 2010, what is the difference between the Cost of computers, communications and other services (% of commerical service exports) in Oman and Cost of computers, communications and other services (% of commerical service exports) in Switzerland?
Make the answer very short. -29.32. In the year 2011, what is the difference between the Cost of computers, communications and other services (% of commerical service exports) in French Polynesia and Cost of computers, communications and other services (% of commerical service exports) in Oman?
Offer a terse response. -12.99. In the year 2011, what is the difference between the Cost of computers, communications and other services (% of commerical service exports) in French Polynesia and Cost of computers, communications and other services (% of commerical service exports) in Switzerland?
Offer a terse response. -39.71. In the year 2011, what is the difference between the Cost of computers, communications and other services (% of commerical service exports) in Oman and Cost of computers, communications and other services (% of commerical service exports) in Switzerland?
Your answer should be very brief. -26.71. In the year 2012, what is the difference between the Cost of computers, communications and other services (% of commerical service exports) in French Polynesia and Cost of computers, communications and other services (% of commerical service exports) in Oman?
Provide a succinct answer. -13.73. In the year 2012, what is the difference between the Cost of computers, communications and other services (% of commerical service exports) in French Polynesia and Cost of computers, communications and other services (% of commerical service exports) in Switzerland?
Make the answer very short. -39.8. In the year 2012, what is the difference between the Cost of computers, communications and other services (% of commerical service exports) of Oman and Cost of computers, communications and other services (% of commerical service exports) of Switzerland?
Provide a succinct answer. -26.07. In the year 2013, what is the difference between the Cost of computers, communications and other services (% of commerical service exports) of French Polynesia and Cost of computers, communications and other services (% of commerical service exports) of Oman?
Your answer should be very brief. -14.11. In the year 2013, what is the difference between the Cost of computers, communications and other services (% of commerical service exports) of French Polynesia and Cost of computers, communications and other services (% of commerical service exports) of Switzerland?
Make the answer very short. -41.84. In the year 2013, what is the difference between the Cost of computers, communications and other services (% of commerical service exports) of Oman and Cost of computers, communications and other services (% of commerical service exports) of Switzerland?
Give a very brief answer. -27.73. What is the ratio of the Cost of computers, communications and other services (% of commerical service exports) of French Polynesia in 2006 to that in 2007?
Offer a very short reply. 1.85. What is the ratio of the Cost of computers, communications and other services (% of commerical service exports) in Oman in 2006 to that in 2007?
Keep it short and to the point. 1.03. What is the ratio of the Cost of computers, communications and other services (% of commerical service exports) in Switzerland in 2006 to that in 2007?
Offer a very short reply. 1.02. What is the ratio of the Cost of computers, communications and other services (% of commerical service exports) in French Polynesia in 2006 to that in 2008?
Make the answer very short. 1.25. What is the ratio of the Cost of computers, communications and other services (% of commerical service exports) in Oman in 2006 to that in 2008?
Offer a very short reply. 1.29. What is the ratio of the Cost of computers, communications and other services (% of commerical service exports) of Switzerland in 2006 to that in 2008?
Your answer should be very brief. 1.03. What is the ratio of the Cost of computers, communications and other services (% of commerical service exports) of French Polynesia in 2006 to that in 2009?
Keep it short and to the point. 1.02. What is the ratio of the Cost of computers, communications and other services (% of commerical service exports) of Oman in 2006 to that in 2009?
Your answer should be very brief. 1.22. What is the ratio of the Cost of computers, communications and other services (% of commerical service exports) of Switzerland in 2006 to that in 2009?
Make the answer very short. 0.98. What is the ratio of the Cost of computers, communications and other services (% of commerical service exports) in French Polynesia in 2006 to that in 2010?
Your response must be concise. 1.25. What is the ratio of the Cost of computers, communications and other services (% of commerical service exports) in Oman in 2006 to that in 2010?
Give a very brief answer. 1.33. What is the ratio of the Cost of computers, communications and other services (% of commerical service exports) of Switzerland in 2006 to that in 2010?
Provide a short and direct response. 0.95. What is the ratio of the Cost of computers, communications and other services (% of commerical service exports) of French Polynesia in 2006 to that in 2011?
Your answer should be very brief. 1.54. What is the ratio of the Cost of computers, communications and other services (% of commerical service exports) of Oman in 2006 to that in 2011?
Keep it short and to the point. 1.18. What is the ratio of the Cost of computers, communications and other services (% of commerical service exports) of Switzerland in 2006 to that in 2011?
Your response must be concise. 0.93. What is the ratio of the Cost of computers, communications and other services (% of commerical service exports) of French Polynesia in 2006 to that in 2012?
Keep it short and to the point. 1.63. What is the ratio of the Cost of computers, communications and other services (% of commerical service exports) of Oman in 2006 to that in 2012?
Give a very brief answer. 1.2. What is the ratio of the Cost of computers, communications and other services (% of commerical service exports) in Switzerland in 2006 to that in 2012?
Your answer should be very brief. 0.95. What is the ratio of the Cost of computers, communications and other services (% of commerical service exports) of French Polynesia in 2006 to that in 2013?
Make the answer very short. 1.75. What is the ratio of the Cost of computers, communications and other services (% of commerical service exports) of Oman in 2006 to that in 2013?
Ensure brevity in your answer.  1.24. What is the ratio of the Cost of computers, communications and other services (% of commerical service exports) of Switzerland in 2006 to that in 2013?
Provide a short and direct response. 0.94. What is the ratio of the Cost of computers, communications and other services (% of commerical service exports) of French Polynesia in 2007 to that in 2008?
Keep it short and to the point. 0.67. What is the ratio of the Cost of computers, communications and other services (% of commerical service exports) in Oman in 2007 to that in 2008?
Make the answer very short. 1.26. What is the ratio of the Cost of computers, communications and other services (% of commerical service exports) of French Polynesia in 2007 to that in 2009?
Keep it short and to the point. 0.55. What is the ratio of the Cost of computers, communications and other services (% of commerical service exports) of Oman in 2007 to that in 2009?
Ensure brevity in your answer.  1.19. What is the ratio of the Cost of computers, communications and other services (% of commerical service exports) of Switzerland in 2007 to that in 2009?
Ensure brevity in your answer.  0.96. What is the ratio of the Cost of computers, communications and other services (% of commerical service exports) of French Polynesia in 2007 to that in 2010?
Offer a terse response. 0.67. What is the ratio of the Cost of computers, communications and other services (% of commerical service exports) in Oman in 2007 to that in 2010?
Keep it short and to the point. 1.3. What is the ratio of the Cost of computers, communications and other services (% of commerical service exports) in Switzerland in 2007 to that in 2010?
Provide a short and direct response. 0.93. What is the ratio of the Cost of computers, communications and other services (% of commerical service exports) in French Polynesia in 2007 to that in 2011?
Your response must be concise. 0.83. What is the ratio of the Cost of computers, communications and other services (% of commerical service exports) in Oman in 2007 to that in 2011?
Provide a succinct answer. 1.15. What is the ratio of the Cost of computers, communications and other services (% of commerical service exports) in Switzerland in 2007 to that in 2011?
Provide a succinct answer. 0.91. What is the ratio of the Cost of computers, communications and other services (% of commerical service exports) of French Polynesia in 2007 to that in 2012?
Provide a succinct answer. 0.88. What is the ratio of the Cost of computers, communications and other services (% of commerical service exports) of Oman in 2007 to that in 2012?
Keep it short and to the point. 1.17. What is the ratio of the Cost of computers, communications and other services (% of commerical service exports) of Switzerland in 2007 to that in 2012?
Give a very brief answer. 0.93. What is the ratio of the Cost of computers, communications and other services (% of commerical service exports) of French Polynesia in 2007 to that in 2013?
Offer a terse response. 0.94. What is the ratio of the Cost of computers, communications and other services (% of commerical service exports) in Oman in 2007 to that in 2013?
Ensure brevity in your answer.  1.2. What is the ratio of the Cost of computers, communications and other services (% of commerical service exports) in Switzerland in 2007 to that in 2013?
Offer a very short reply. 0.92. What is the ratio of the Cost of computers, communications and other services (% of commerical service exports) in French Polynesia in 2008 to that in 2009?
Make the answer very short. 0.82. What is the ratio of the Cost of computers, communications and other services (% of commerical service exports) of Oman in 2008 to that in 2009?
Provide a succinct answer. 0.95. What is the ratio of the Cost of computers, communications and other services (% of commerical service exports) in Switzerland in 2008 to that in 2009?
Offer a terse response. 0.95. What is the ratio of the Cost of computers, communications and other services (% of commerical service exports) of French Polynesia in 2008 to that in 2010?
Your answer should be compact. 1. What is the ratio of the Cost of computers, communications and other services (% of commerical service exports) in Oman in 2008 to that in 2010?
Offer a very short reply. 1.03. What is the ratio of the Cost of computers, communications and other services (% of commerical service exports) in Switzerland in 2008 to that in 2010?
Your answer should be compact. 0.92. What is the ratio of the Cost of computers, communications and other services (% of commerical service exports) in French Polynesia in 2008 to that in 2011?
Ensure brevity in your answer.  1.23. What is the ratio of the Cost of computers, communications and other services (% of commerical service exports) in Oman in 2008 to that in 2011?
Your answer should be compact. 0.92. What is the ratio of the Cost of computers, communications and other services (% of commerical service exports) in Switzerland in 2008 to that in 2011?
Provide a short and direct response. 0.9. What is the ratio of the Cost of computers, communications and other services (% of commerical service exports) of French Polynesia in 2008 to that in 2012?
Provide a succinct answer. 1.31. What is the ratio of the Cost of computers, communications and other services (% of commerical service exports) in Oman in 2008 to that in 2012?
Offer a terse response. 0.93. What is the ratio of the Cost of computers, communications and other services (% of commerical service exports) in Switzerland in 2008 to that in 2012?
Ensure brevity in your answer.  0.92. What is the ratio of the Cost of computers, communications and other services (% of commerical service exports) of French Polynesia in 2008 to that in 2013?
Ensure brevity in your answer.  1.4. What is the ratio of the Cost of computers, communications and other services (% of commerical service exports) of Oman in 2008 to that in 2013?
Provide a short and direct response. 0.96. What is the ratio of the Cost of computers, communications and other services (% of commerical service exports) in Switzerland in 2008 to that in 2013?
Your answer should be very brief. 0.91. What is the ratio of the Cost of computers, communications and other services (% of commerical service exports) in French Polynesia in 2009 to that in 2010?
Your answer should be very brief. 1.22. What is the ratio of the Cost of computers, communications and other services (% of commerical service exports) in Oman in 2009 to that in 2010?
Your answer should be very brief. 1.09. What is the ratio of the Cost of computers, communications and other services (% of commerical service exports) in Switzerland in 2009 to that in 2010?
Ensure brevity in your answer.  0.97. What is the ratio of the Cost of computers, communications and other services (% of commerical service exports) in French Polynesia in 2009 to that in 2011?
Provide a short and direct response. 1.5. What is the ratio of the Cost of computers, communications and other services (% of commerical service exports) of Oman in 2009 to that in 2011?
Ensure brevity in your answer.  0.97. What is the ratio of the Cost of computers, communications and other services (% of commerical service exports) in Switzerland in 2009 to that in 2011?
Keep it short and to the point. 0.95. What is the ratio of the Cost of computers, communications and other services (% of commerical service exports) of French Polynesia in 2009 to that in 2012?
Offer a very short reply. 1.59. What is the ratio of the Cost of computers, communications and other services (% of commerical service exports) in Oman in 2009 to that in 2012?
Your answer should be very brief. 0.98. What is the ratio of the Cost of computers, communications and other services (% of commerical service exports) of Switzerland in 2009 to that in 2012?
Offer a very short reply. 0.97. What is the ratio of the Cost of computers, communications and other services (% of commerical service exports) in French Polynesia in 2009 to that in 2013?
Make the answer very short. 1.71. What is the ratio of the Cost of computers, communications and other services (% of commerical service exports) in Oman in 2009 to that in 2013?
Your answer should be compact. 1.01. What is the ratio of the Cost of computers, communications and other services (% of commerical service exports) in Switzerland in 2009 to that in 2013?
Keep it short and to the point. 0.96. What is the ratio of the Cost of computers, communications and other services (% of commerical service exports) in French Polynesia in 2010 to that in 2011?
Give a very brief answer. 1.24. What is the ratio of the Cost of computers, communications and other services (% of commerical service exports) of Oman in 2010 to that in 2011?
Offer a very short reply. 0.89. What is the ratio of the Cost of computers, communications and other services (% of commerical service exports) in Switzerland in 2010 to that in 2011?
Give a very brief answer. 0.98. What is the ratio of the Cost of computers, communications and other services (% of commerical service exports) of French Polynesia in 2010 to that in 2012?
Ensure brevity in your answer.  1.31. What is the ratio of the Cost of computers, communications and other services (% of commerical service exports) in Oman in 2010 to that in 2012?
Ensure brevity in your answer.  0.9. What is the ratio of the Cost of computers, communications and other services (% of commerical service exports) of French Polynesia in 2010 to that in 2013?
Provide a short and direct response. 1.4. What is the ratio of the Cost of computers, communications and other services (% of commerical service exports) of Oman in 2010 to that in 2013?
Make the answer very short. 0.93. What is the ratio of the Cost of computers, communications and other services (% of commerical service exports) in Switzerland in 2010 to that in 2013?
Offer a very short reply. 0.99. What is the ratio of the Cost of computers, communications and other services (% of commerical service exports) of French Polynesia in 2011 to that in 2012?
Your response must be concise. 1.06. What is the ratio of the Cost of computers, communications and other services (% of commerical service exports) of Oman in 2011 to that in 2012?
Your response must be concise. 1.01. What is the ratio of the Cost of computers, communications and other services (% of commerical service exports) of Switzerland in 2011 to that in 2012?
Provide a succinct answer. 1.02. What is the ratio of the Cost of computers, communications and other services (% of commerical service exports) of French Polynesia in 2011 to that in 2013?
Your response must be concise. 1.13. What is the ratio of the Cost of computers, communications and other services (% of commerical service exports) in Oman in 2011 to that in 2013?
Provide a short and direct response. 1.04. What is the ratio of the Cost of computers, communications and other services (% of commerical service exports) in Switzerland in 2011 to that in 2013?
Give a very brief answer. 1.01. What is the ratio of the Cost of computers, communications and other services (% of commerical service exports) of French Polynesia in 2012 to that in 2013?
Provide a succinct answer. 1.07. What is the ratio of the Cost of computers, communications and other services (% of commerical service exports) of Oman in 2012 to that in 2013?
Keep it short and to the point. 1.03. What is the difference between the highest and the second highest Cost of computers, communications and other services (% of commerical service exports) of French Polynesia?
Your answer should be very brief. 0.81. What is the difference between the highest and the second highest Cost of computers, communications and other services (% of commerical service exports) in Oman?
Your answer should be compact. 1.09. What is the difference between the highest and the second highest Cost of computers, communications and other services (% of commerical service exports) of Switzerland?
Provide a short and direct response. 0.47. What is the difference between the highest and the lowest Cost of computers, communications and other services (% of commerical service exports) of French Polynesia?
Ensure brevity in your answer.  15.65. What is the difference between the highest and the lowest Cost of computers, communications and other services (% of commerical service exports) of Oman?
Provide a succinct answer. 10.39. What is the difference between the highest and the lowest Cost of computers, communications and other services (% of commerical service exports) of Switzerland?
Ensure brevity in your answer.  6. 